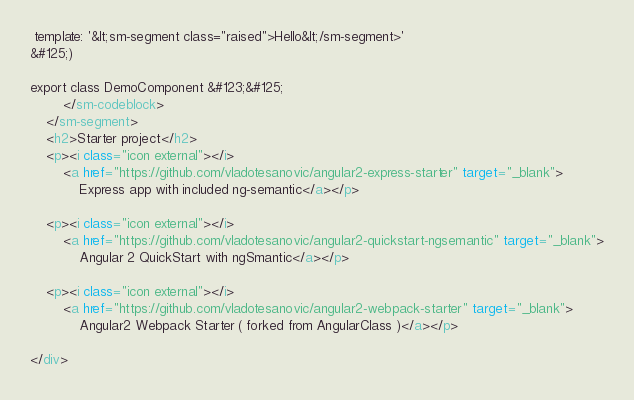<code> <loc_0><loc_0><loc_500><loc_500><_HTML_> template: '&lt;sm-segment class="raised">Hello&lt;/sm-segment>'
&#125;)

export class DemoComponent &#123;&#125;
        </sm-codeblock>
    </sm-segment>
    <h2>Starter project</h2>
    <p><i class="icon external"></i>
        <a href="https://github.com/vladotesanovic/angular2-express-starter" target="_blank">
            Express app with included ng-semantic</a></p>

    <p><i class="icon external"></i>
        <a href="https://github.com/vladotesanovic/angular2-quickstart-ngsemantic" target="_blank">
            Angular 2 QuickStart with ngSmantic</a></p>

    <p><i class="icon external"></i>
        <a href="https://github.com/vladotesanovic/angular2-webpack-starter" target="_blank">
            Angular2 Webpack Starter ( forked from AngularClass )</a></p>

</div>
</code> 